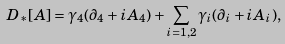Convert formula to latex. <formula><loc_0><loc_0><loc_500><loc_500>D _ { * } [ A ] = \gamma _ { 4 } ( \partial _ { 4 } + i A _ { 4 } ) + \sum _ { i = 1 , 2 } \gamma _ { i } ( \partial _ { i } + i A _ { i } ) ,</formula> 